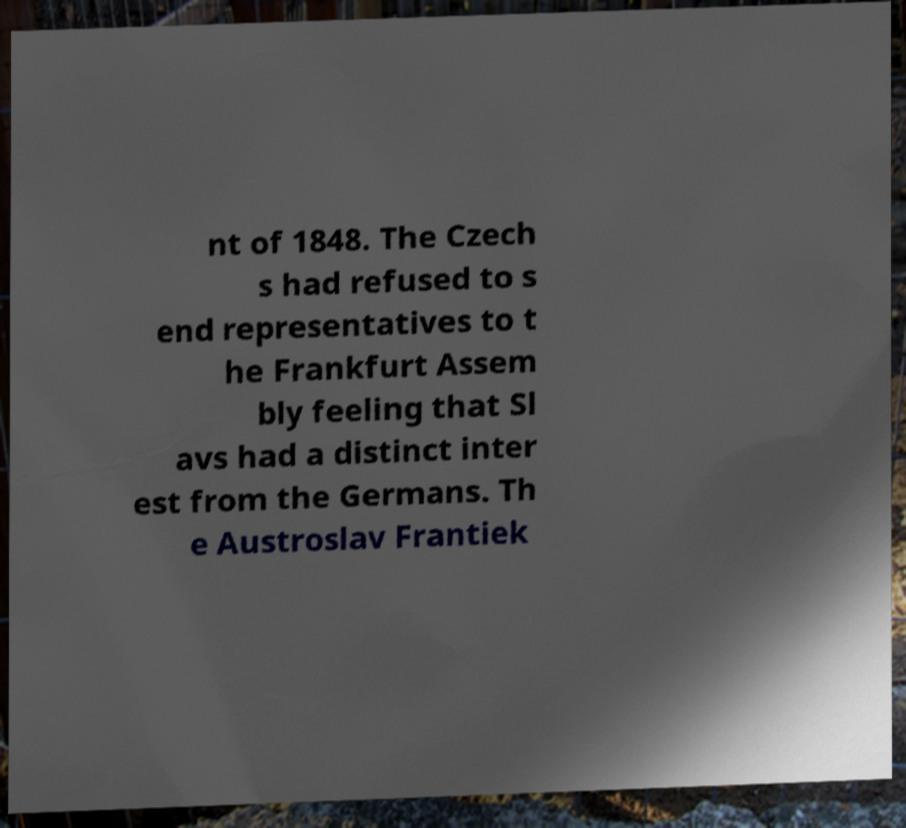Can you read and provide the text displayed in the image?This photo seems to have some interesting text. Can you extract and type it out for me? nt of 1848. The Czech s had refused to s end representatives to t he Frankfurt Assem bly feeling that Sl avs had a distinct inter est from the Germans. Th e Austroslav Frantiek 